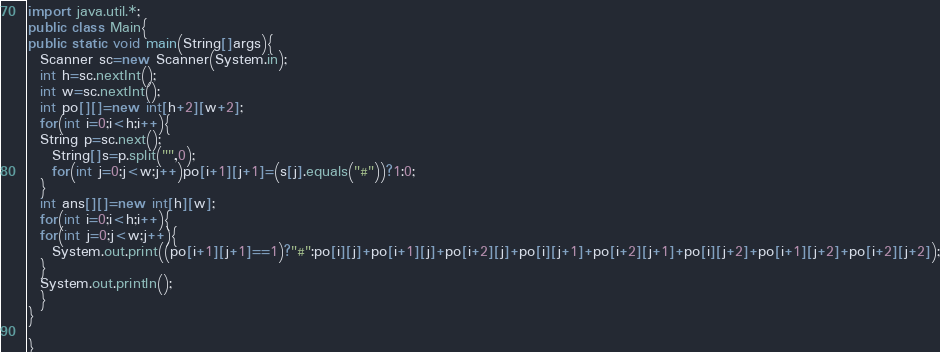<code> <loc_0><loc_0><loc_500><loc_500><_Java_>import java.util.*;
public class Main{
public static void main(String[]args){
  Scanner sc=new Scanner(System.in);
  int h=sc.nextInt();
  int w=sc.nextInt();
  int po[][]=new int[h+2][w+2];
  for(int i=0;i<h;i++){
  String p=sc.next();
    String[]s=p.split("",0);
    for(int j=0;j<w;j++)po[i+1][j+1]=(s[j].equals("#"))?1:0;
  }
  int ans[][]=new int[h][w];
  for(int i=0;i<h;i++){
  for(int j=0;j<w;j++){
    System.out.print((po[i+1][j+1]==1)?"#":po[i][j]+po[i+1][j]+po[i+2][j]+po[i][j+1]+po[i+2][j+1]+po[i][j+2]+po[i+1][j+2]+po[i+2][j+2]);
  }
  System.out.println();
  }
}

}
</code> 